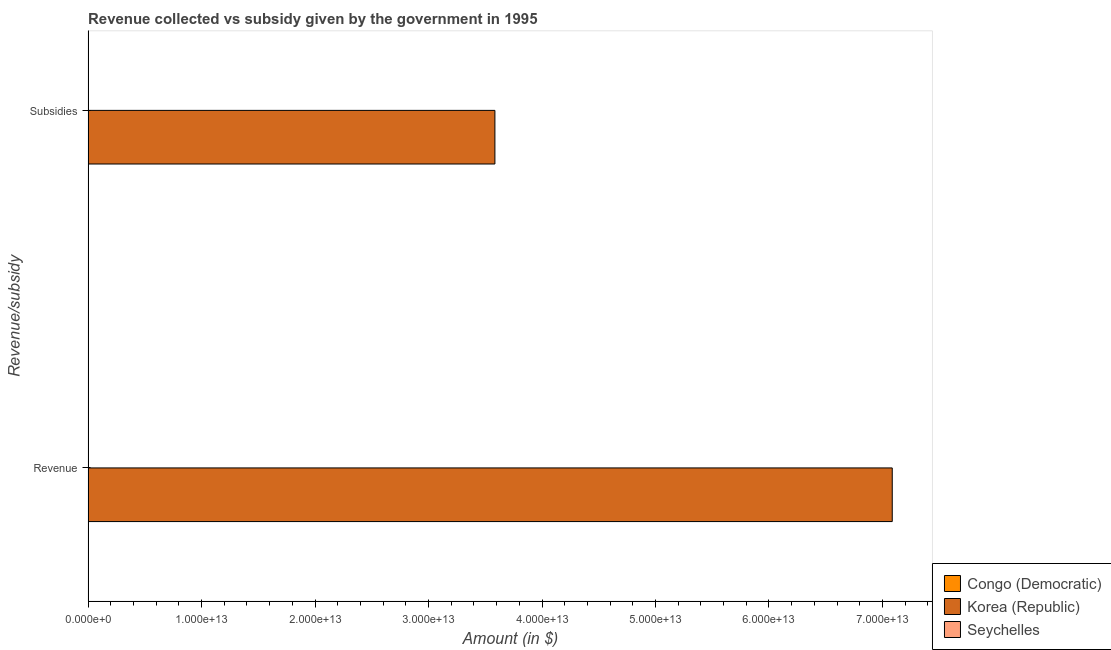How many different coloured bars are there?
Your answer should be very brief. 3. Are the number of bars per tick equal to the number of legend labels?
Your answer should be very brief. Yes. How many bars are there on the 1st tick from the bottom?
Your answer should be very brief. 3. What is the label of the 2nd group of bars from the top?
Make the answer very short. Revenue. What is the amount of subsidies given in Congo (Democratic)?
Provide a short and direct response. 5.50e+05. Across all countries, what is the maximum amount of subsidies given?
Offer a terse response. 3.58e+13. Across all countries, what is the minimum amount of subsidies given?
Make the answer very short. 5.50e+05. In which country was the amount of revenue collected minimum?
Keep it short and to the point. Congo (Democratic). What is the total amount of revenue collected in the graph?
Ensure brevity in your answer.  7.09e+13. What is the difference between the amount of subsidies given in Seychelles and that in Congo (Democratic)?
Give a very brief answer. 2.48e+08. What is the difference between the amount of subsidies given in Seychelles and the amount of revenue collected in Congo (Democratic)?
Your answer should be compact. 2.27e+08. What is the average amount of subsidies given per country?
Provide a succinct answer. 1.19e+13. What is the difference between the amount of subsidies given and amount of revenue collected in Congo (Democratic)?
Your answer should be very brief. -2.06e+07. What is the ratio of the amount of subsidies given in Congo (Democratic) to that in Seychelles?
Keep it short and to the point. 0. What does the 1st bar from the top in Revenue represents?
Your answer should be compact. Seychelles. How many bars are there?
Make the answer very short. 6. Are all the bars in the graph horizontal?
Make the answer very short. Yes. What is the difference between two consecutive major ticks on the X-axis?
Keep it short and to the point. 1.00e+13. Are the values on the major ticks of X-axis written in scientific E-notation?
Provide a succinct answer. Yes. Does the graph contain any zero values?
Make the answer very short. No. Where does the legend appear in the graph?
Make the answer very short. Bottom right. How many legend labels are there?
Your response must be concise. 3. What is the title of the graph?
Your response must be concise. Revenue collected vs subsidy given by the government in 1995. What is the label or title of the X-axis?
Provide a succinct answer. Amount (in $). What is the label or title of the Y-axis?
Keep it short and to the point. Revenue/subsidy. What is the Amount (in $) in Congo (Democratic) in Revenue?
Provide a succinct answer. 2.12e+07. What is the Amount (in $) in Korea (Republic) in Revenue?
Make the answer very short. 7.09e+13. What is the Amount (in $) in Seychelles in Revenue?
Provide a succinct answer. 1.06e+09. What is the Amount (in $) in Congo (Democratic) in Subsidies?
Offer a terse response. 5.50e+05. What is the Amount (in $) of Korea (Republic) in Subsidies?
Make the answer very short. 3.58e+13. What is the Amount (in $) of Seychelles in Subsidies?
Make the answer very short. 2.48e+08. Across all Revenue/subsidy, what is the maximum Amount (in $) in Congo (Democratic)?
Keep it short and to the point. 2.12e+07. Across all Revenue/subsidy, what is the maximum Amount (in $) of Korea (Republic)?
Offer a terse response. 7.09e+13. Across all Revenue/subsidy, what is the maximum Amount (in $) of Seychelles?
Your answer should be very brief. 1.06e+09. Across all Revenue/subsidy, what is the minimum Amount (in $) in Korea (Republic)?
Make the answer very short. 3.58e+13. Across all Revenue/subsidy, what is the minimum Amount (in $) in Seychelles?
Give a very brief answer. 2.48e+08. What is the total Amount (in $) of Congo (Democratic) in the graph?
Provide a short and direct response. 2.18e+07. What is the total Amount (in $) in Korea (Republic) in the graph?
Your answer should be very brief. 1.07e+14. What is the total Amount (in $) of Seychelles in the graph?
Provide a succinct answer. 1.31e+09. What is the difference between the Amount (in $) in Congo (Democratic) in Revenue and that in Subsidies?
Provide a short and direct response. 2.06e+07. What is the difference between the Amount (in $) in Korea (Republic) in Revenue and that in Subsidies?
Keep it short and to the point. 3.50e+13. What is the difference between the Amount (in $) in Seychelles in Revenue and that in Subsidies?
Make the answer very short. 8.10e+08. What is the difference between the Amount (in $) in Congo (Democratic) in Revenue and the Amount (in $) in Korea (Republic) in Subsidies?
Give a very brief answer. -3.58e+13. What is the difference between the Amount (in $) in Congo (Democratic) in Revenue and the Amount (in $) in Seychelles in Subsidies?
Offer a terse response. -2.27e+08. What is the difference between the Amount (in $) of Korea (Republic) in Revenue and the Amount (in $) of Seychelles in Subsidies?
Make the answer very short. 7.09e+13. What is the average Amount (in $) of Congo (Democratic) per Revenue/subsidy?
Offer a terse response. 1.09e+07. What is the average Amount (in $) in Korea (Republic) per Revenue/subsidy?
Ensure brevity in your answer.  5.34e+13. What is the average Amount (in $) in Seychelles per Revenue/subsidy?
Offer a very short reply. 6.53e+08. What is the difference between the Amount (in $) in Congo (Democratic) and Amount (in $) in Korea (Republic) in Revenue?
Ensure brevity in your answer.  -7.09e+13. What is the difference between the Amount (in $) in Congo (Democratic) and Amount (in $) in Seychelles in Revenue?
Give a very brief answer. -1.04e+09. What is the difference between the Amount (in $) of Korea (Republic) and Amount (in $) of Seychelles in Revenue?
Offer a very short reply. 7.09e+13. What is the difference between the Amount (in $) in Congo (Democratic) and Amount (in $) in Korea (Republic) in Subsidies?
Provide a short and direct response. -3.58e+13. What is the difference between the Amount (in $) in Congo (Democratic) and Amount (in $) in Seychelles in Subsidies?
Provide a succinct answer. -2.48e+08. What is the difference between the Amount (in $) of Korea (Republic) and Amount (in $) of Seychelles in Subsidies?
Your response must be concise. 3.58e+13. What is the ratio of the Amount (in $) in Congo (Democratic) in Revenue to that in Subsidies?
Provide a succinct answer. 38.55. What is the ratio of the Amount (in $) in Korea (Republic) in Revenue to that in Subsidies?
Keep it short and to the point. 1.98. What is the ratio of the Amount (in $) of Seychelles in Revenue to that in Subsidies?
Your answer should be compact. 4.26. What is the difference between the highest and the second highest Amount (in $) in Congo (Democratic)?
Offer a very short reply. 2.06e+07. What is the difference between the highest and the second highest Amount (in $) of Korea (Republic)?
Provide a succinct answer. 3.50e+13. What is the difference between the highest and the second highest Amount (in $) in Seychelles?
Ensure brevity in your answer.  8.10e+08. What is the difference between the highest and the lowest Amount (in $) in Congo (Democratic)?
Your response must be concise. 2.06e+07. What is the difference between the highest and the lowest Amount (in $) in Korea (Republic)?
Provide a short and direct response. 3.50e+13. What is the difference between the highest and the lowest Amount (in $) in Seychelles?
Keep it short and to the point. 8.10e+08. 